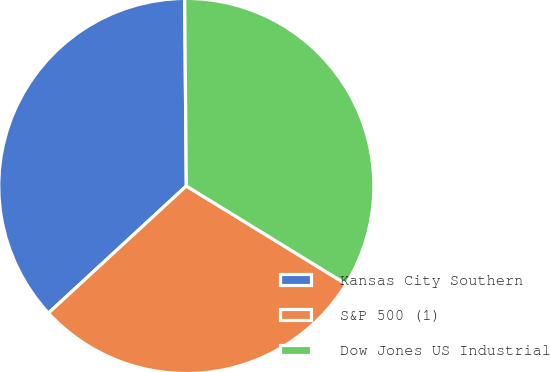<chart> <loc_0><loc_0><loc_500><loc_500><pie_chart><fcel>Kansas City Southern<fcel>S&P 500 (1)<fcel>Dow Jones US Industrial<nl><fcel>36.71%<fcel>29.38%<fcel>33.9%<nl></chart> 